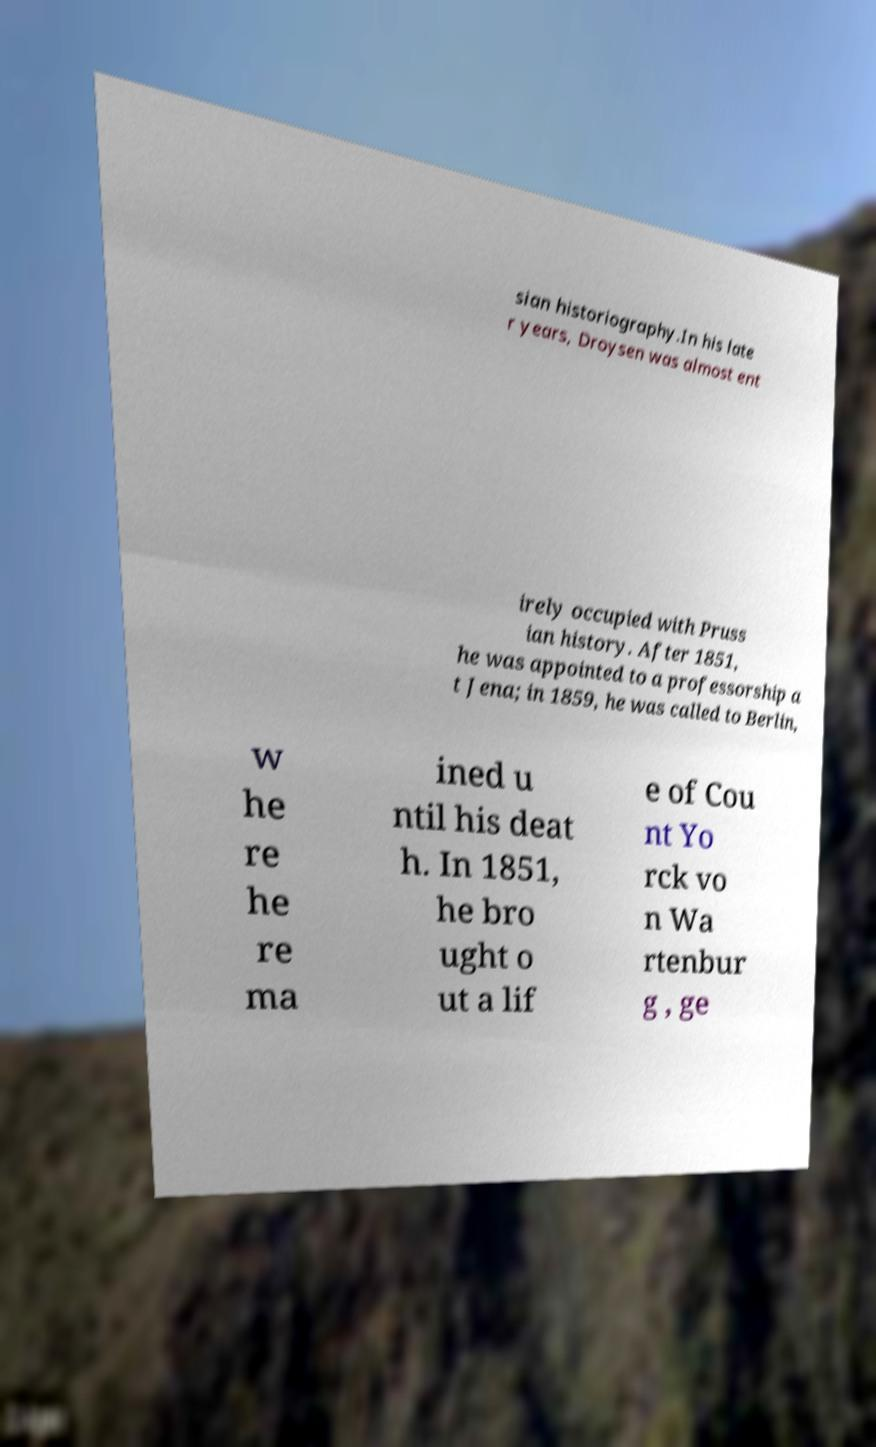Please identify and transcribe the text found in this image. sian historiography.In his late r years, Droysen was almost ent irely occupied with Pruss ian history. After 1851, he was appointed to a professorship a t Jena; in 1859, he was called to Berlin, w he re he re ma ined u ntil his deat h. In 1851, he bro ught o ut a lif e of Cou nt Yo rck vo n Wa rtenbur g , ge 